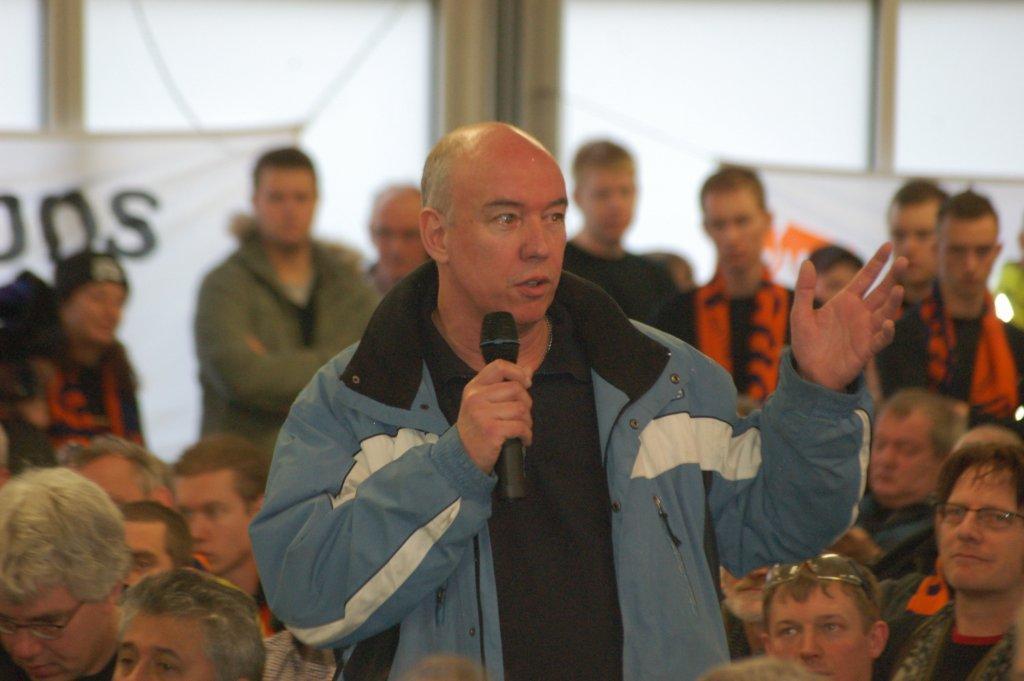Could you give a brief overview of what you see in this image? In the middle a man is standing and speaking in the microphone, he wore coat, shirt. At the bottom few people are sitting, at the back side few persons are standing. Behind them there are glass walls in this image. 